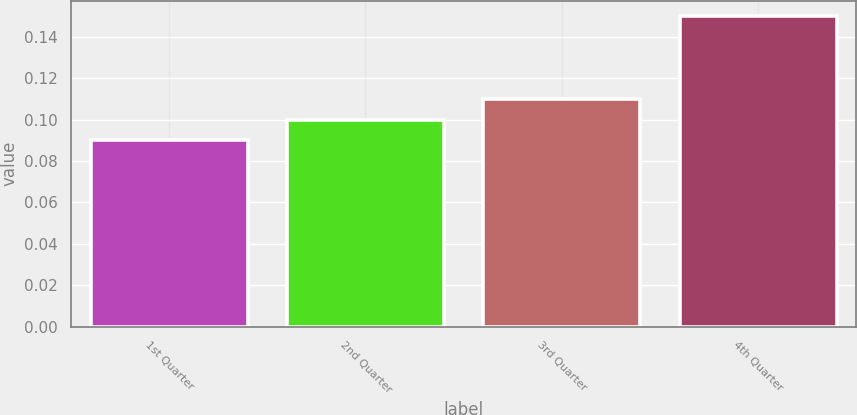Convert chart. <chart><loc_0><loc_0><loc_500><loc_500><bar_chart><fcel>1st Quarter<fcel>2nd Quarter<fcel>3rd Quarter<fcel>4th Quarter<nl><fcel>0.09<fcel>0.1<fcel>0.11<fcel>0.15<nl></chart> 